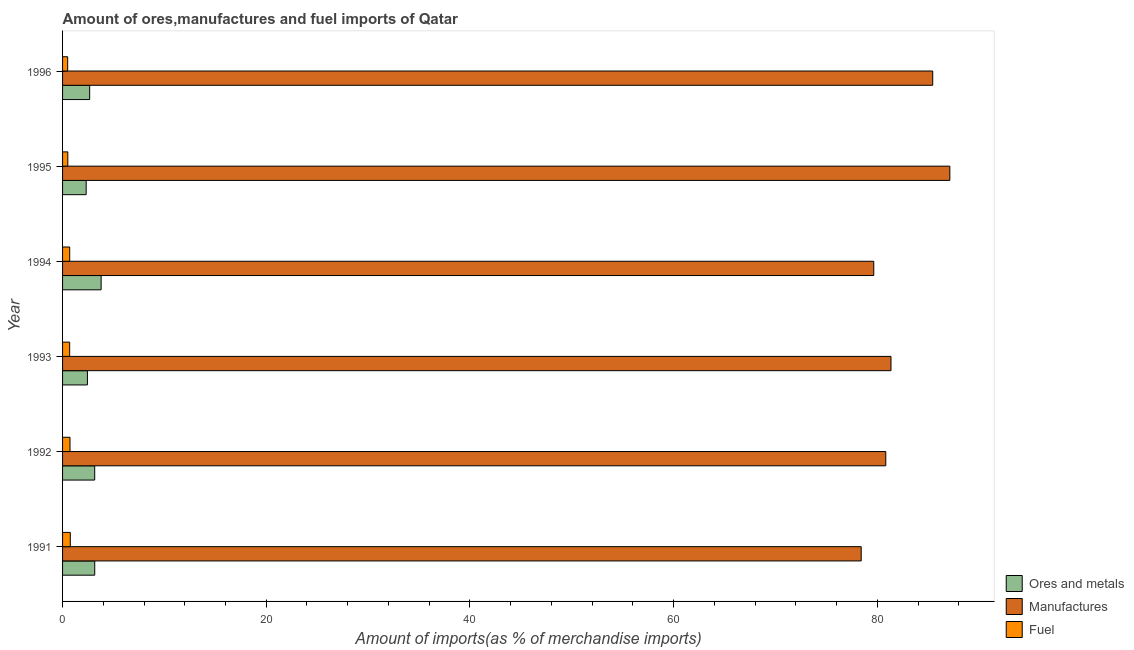How many different coloured bars are there?
Your response must be concise. 3. Are the number of bars per tick equal to the number of legend labels?
Ensure brevity in your answer.  Yes. How many bars are there on the 6th tick from the top?
Keep it short and to the point. 3. How many bars are there on the 1st tick from the bottom?
Make the answer very short. 3. What is the percentage of ores and metals imports in 1991?
Ensure brevity in your answer.  3.16. Across all years, what is the maximum percentage of manufactures imports?
Make the answer very short. 87.12. Across all years, what is the minimum percentage of manufactures imports?
Give a very brief answer. 78.42. In which year was the percentage of manufactures imports maximum?
Your answer should be very brief. 1995. What is the total percentage of ores and metals imports in the graph?
Your answer should be very brief. 17.52. What is the difference between the percentage of fuel imports in 1991 and that in 1995?
Your answer should be very brief. 0.24. What is the difference between the percentage of ores and metals imports in 1995 and the percentage of manufactures imports in 1992?
Provide a short and direct response. -78.51. What is the average percentage of manufactures imports per year?
Your answer should be very brief. 82.13. In the year 1991, what is the difference between the percentage of manufactures imports and percentage of fuel imports?
Offer a terse response. 77.66. In how many years, is the percentage of manufactures imports greater than 72 %?
Your answer should be compact. 6. What is the ratio of the percentage of ores and metals imports in 1991 to that in 1993?
Your response must be concise. 1.29. Is the percentage of fuel imports in 1995 less than that in 1996?
Provide a short and direct response. No. Is the difference between the percentage of manufactures imports in 1993 and 1996 greater than the difference between the percentage of ores and metals imports in 1993 and 1996?
Keep it short and to the point. No. What is the difference between the highest and the second highest percentage of ores and metals imports?
Give a very brief answer. 0.63. What is the difference between the highest and the lowest percentage of ores and metals imports?
Provide a short and direct response. 1.47. In how many years, is the percentage of fuel imports greater than the average percentage of fuel imports taken over all years?
Your answer should be compact. 4. What does the 3rd bar from the top in 1996 represents?
Provide a succinct answer. Ores and metals. What does the 3rd bar from the bottom in 1996 represents?
Your answer should be very brief. Fuel. What is the difference between two consecutive major ticks on the X-axis?
Make the answer very short. 20. How are the legend labels stacked?
Ensure brevity in your answer.  Vertical. What is the title of the graph?
Ensure brevity in your answer.  Amount of ores,manufactures and fuel imports of Qatar. What is the label or title of the X-axis?
Ensure brevity in your answer.  Amount of imports(as % of merchandise imports). What is the Amount of imports(as % of merchandise imports) in Ores and metals in 1991?
Give a very brief answer. 3.16. What is the Amount of imports(as % of merchandise imports) of Manufactures in 1991?
Offer a terse response. 78.42. What is the Amount of imports(as % of merchandise imports) in Fuel in 1991?
Offer a very short reply. 0.76. What is the Amount of imports(as % of merchandise imports) in Ores and metals in 1992?
Give a very brief answer. 3.16. What is the Amount of imports(as % of merchandise imports) of Manufactures in 1992?
Keep it short and to the point. 80.83. What is the Amount of imports(as % of merchandise imports) of Fuel in 1992?
Your answer should be very brief. 0.73. What is the Amount of imports(as % of merchandise imports) in Ores and metals in 1993?
Keep it short and to the point. 2.44. What is the Amount of imports(as % of merchandise imports) in Manufactures in 1993?
Provide a short and direct response. 81.34. What is the Amount of imports(as % of merchandise imports) of Fuel in 1993?
Your answer should be compact. 0.7. What is the Amount of imports(as % of merchandise imports) in Ores and metals in 1994?
Offer a very short reply. 3.79. What is the Amount of imports(as % of merchandise imports) in Manufactures in 1994?
Provide a succinct answer. 79.65. What is the Amount of imports(as % of merchandise imports) of Fuel in 1994?
Provide a short and direct response. 0.7. What is the Amount of imports(as % of merchandise imports) in Ores and metals in 1995?
Give a very brief answer. 2.32. What is the Amount of imports(as % of merchandise imports) in Manufactures in 1995?
Provide a short and direct response. 87.12. What is the Amount of imports(as % of merchandise imports) of Fuel in 1995?
Ensure brevity in your answer.  0.52. What is the Amount of imports(as % of merchandise imports) of Ores and metals in 1996?
Your answer should be very brief. 2.66. What is the Amount of imports(as % of merchandise imports) in Manufactures in 1996?
Provide a succinct answer. 85.44. What is the Amount of imports(as % of merchandise imports) in Fuel in 1996?
Keep it short and to the point. 0.5. Across all years, what is the maximum Amount of imports(as % of merchandise imports) of Ores and metals?
Offer a very short reply. 3.79. Across all years, what is the maximum Amount of imports(as % of merchandise imports) in Manufactures?
Provide a succinct answer. 87.12. Across all years, what is the maximum Amount of imports(as % of merchandise imports) in Fuel?
Offer a terse response. 0.76. Across all years, what is the minimum Amount of imports(as % of merchandise imports) of Ores and metals?
Your answer should be very brief. 2.32. Across all years, what is the minimum Amount of imports(as % of merchandise imports) of Manufactures?
Make the answer very short. 78.42. Across all years, what is the minimum Amount of imports(as % of merchandise imports) of Fuel?
Provide a succinct answer. 0.5. What is the total Amount of imports(as % of merchandise imports) in Ores and metals in the graph?
Offer a very short reply. 17.52. What is the total Amount of imports(as % of merchandise imports) of Manufactures in the graph?
Offer a very short reply. 492.8. What is the total Amount of imports(as % of merchandise imports) of Fuel in the graph?
Provide a succinct answer. 3.9. What is the difference between the Amount of imports(as % of merchandise imports) in Ores and metals in 1991 and that in 1992?
Offer a terse response. 0. What is the difference between the Amount of imports(as % of merchandise imports) in Manufactures in 1991 and that in 1992?
Provide a succinct answer. -2.41. What is the difference between the Amount of imports(as % of merchandise imports) of Fuel in 1991 and that in 1992?
Your answer should be compact. 0.03. What is the difference between the Amount of imports(as % of merchandise imports) in Ores and metals in 1991 and that in 1993?
Provide a short and direct response. 0.72. What is the difference between the Amount of imports(as % of merchandise imports) in Manufactures in 1991 and that in 1993?
Give a very brief answer. -2.92. What is the difference between the Amount of imports(as % of merchandise imports) of Fuel in 1991 and that in 1993?
Your answer should be very brief. 0.06. What is the difference between the Amount of imports(as % of merchandise imports) in Ores and metals in 1991 and that in 1994?
Offer a terse response. -0.63. What is the difference between the Amount of imports(as % of merchandise imports) in Manufactures in 1991 and that in 1994?
Keep it short and to the point. -1.23. What is the difference between the Amount of imports(as % of merchandise imports) of Fuel in 1991 and that in 1994?
Offer a very short reply. 0.06. What is the difference between the Amount of imports(as % of merchandise imports) of Ores and metals in 1991 and that in 1995?
Give a very brief answer. 0.84. What is the difference between the Amount of imports(as % of merchandise imports) in Manufactures in 1991 and that in 1995?
Provide a short and direct response. -8.7. What is the difference between the Amount of imports(as % of merchandise imports) in Fuel in 1991 and that in 1995?
Your answer should be compact. 0.24. What is the difference between the Amount of imports(as % of merchandise imports) in Ores and metals in 1991 and that in 1996?
Offer a terse response. 0.5. What is the difference between the Amount of imports(as % of merchandise imports) of Manufactures in 1991 and that in 1996?
Provide a succinct answer. -7.02. What is the difference between the Amount of imports(as % of merchandise imports) in Fuel in 1991 and that in 1996?
Your answer should be very brief. 0.26. What is the difference between the Amount of imports(as % of merchandise imports) in Ores and metals in 1992 and that in 1993?
Your answer should be compact. 0.72. What is the difference between the Amount of imports(as % of merchandise imports) of Manufactures in 1992 and that in 1993?
Make the answer very short. -0.51. What is the difference between the Amount of imports(as % of merchandise imports) of Fuel in 1992 and that in 1993?
Your answer should be compact. 0.03. What is the difference between the Amount of imports(as % of merchandise imports) of Ores and metals in 1992 and that in 1994?
Your response must be concise. -0.63. What is the difference between the Amount of imports(as % of merchandise imports) of Manufactures in 1992 and that in 1994?
Provide a short and direct response. 1.18. What is the difference between the Amount of imports(as % of merchandise imports) of Fuel in 1992 and that in 1994?
Your answer should be very brief. 0.03. What is the difference between the Amount of imports(as % of merchandise imports) in Ores and metals in 1992 and that in 1995?
Ensure brevity in your answer.  0.84. What is the difference between the Amount of imports(as % of merchandise imports) in Manufactures in 1992 and that in 1995?
Offer a very short reply. -6.29. What is the difference between the Amount of imports(as % of merchandise imports) of Fuel in 1992 and that in 1995?
Provide a short and direct response. 0.21. What is the difference between the Amount of imports(as % of merchandise imports) in Ores and metals in 1992 and that in 1996?
Provide a short and direct response. 0.49. What is the difference between the Amount of imports(as % of merchandise imports) in Manufactures in 1992 and that in 1996?
Your answer should be compact. -4.61. What is the difference between the Amount of imports(as % of merchandise imports) in Fuel in 1992 and that in 1996?
Your answer should be very brief. 0.23. What is the difference between the Amount of imports(as % of merchandise imports) in Ores and metals in 1993 and that in 1994?
Your answer should be very brief. -1.35. What is the difference between the Amount of imports(as % of merchandise imports) of Manufactures in 1993 and that in 1994?
Provide a succinct answer. 1.69. What is the difference between the Amount of imports(as % of merchandise imports) in Fuel in 1993 and that in 1994?
Make the answer very short. -0. What is the difference between the Amount of imports(as % of merchandise imports) in Ores and metals in 1993 and that in 1995?
Give a very brief answer. 0.12. What is the difference between the Amount of imports(as % of merchandise imports) in Manufactures in 1993 and that in 1995?
Your response must be concise. -5.78. What is the difference between the Amount of imports(as % of merchandise imports) in Fuel in 1993 and that in 1995?
Your answer should be compact. 0.18. What is the difference between the Amount of imports(as % of merchandise imports) in Ores and metals in 1993 and that in 1996?
Offer a very short reply. -0.22. What is the difference between the Amount of imports(as % of merchandise imports) of Manufactures in 1993 and that in 1996?
Make the answer very short. -4.1. What is the difference between the Amount of imports(as % of merchandise imports) in Fuel in 1993 and that in 1996?
Ensure brevity in your answer.  0.2. What is the difference between the Amount of imports(as % of merchandise imports) in Ores and metals in 1994 and that in 1995?
Give a very brief answer. 1.47. What is the difference between the Amount of imports(as % of merchandise imports) in Manufactures in 1994 and that in 1995?
Your answer should be compact. -7.47. What is the difference between the Amount of imports(as % of merchandise imports) in Fuel in 1994 and that in 1995?
Make the answer very short. 0.18. What is the difference between the Amount of imports(as % of merchandise imports) in Manufactures in 1994 and that in 1996?
Your answer should be compact. -5.79. What is the difference between the Amount of imports(as % of merchandise imports) in Ores and metals in 1995 and that in 1996?
Provide a succinct answer. -0.34. What is the difference between the Amount of imports(as % of merchandise imports) in Manufactures in 1995 and that in 1996?
Offer a terse response. 1.68. What is the difference between the Amount of imports(as % of merchandise imports) of Fuel in 1995 and that in 1996?
Your response must be concise. 0.02. What is the difference between the Amount of imports(as % of merchandise imports) of Ores and metals in 1991 and the Amount of imports(as % of merchandise imports) of Manufactures in 1992?
Your answer should be very brief. -77.67. What is the difference between the Amount of imports(as % of merchandise imports) of Ores and metals in 1991 and the Amount of imports(as % of merchandise imports) of Fuel in 1992?
Make the answer very short. 2.43. What is the difference between the Amount of imports(as % of merchandise imports) in Manufactures in 1991 and the Amount of imports(as % of merchandise imports) in Fuel in 1992?
Give a very brief answer. 77.69. What is the difference between the Amount of imports(as % of merchandise imports) in Ores and metals in 1991 and the Amount of imports(as % of merchandise imports) in Manufactures in 1993?
Your answer should be compact. -78.18. What is the difference between the Amount of imports(as % of merchandise imports) of Ores and metals in 1991 and the Amount of imports(as % of merchandise imports) of Fuel in 1993?
Your answer should be compact. 2.46. What is the difference between the Amount of imports(as % of merchandise imports) in Manufactures in 1991 and the Amount of imports(as % of merchandise imports) in Fuel in 1993?
Your answer should be compact. 77.72. What is the difference between the Amount of imports(as % of merchandise imports) in Ores and metals in 1991 and the Amount of imports(as % of merchandise imports) in Manufactures in 1994?
Provide a succinct answer. -76.49. What is the difference between the Amount of imports(as % of merchandise imports) in Ores and metals in 1991 and the Amount of imports(as % of merchandise imports) in Fuel in 1994?
Provide a short and direct response. 2.46. What is the difference between the Amount of imports(as % of merchandise imports) of Manufactures in 1991 and the Amount of imports(as % of merchandise imports) of Fuel in 1994?
Offer a very short reply. 77.72. What is the difference between the Amount of imports(as % of merchandise imports) of Ores and metals in 1991 and the Amount of imports(as % of merchandise imports) of Manufactures in 1995?
Ensure brevity in your answer.  -83.96. What is the difference between the Amount of imports(as % of merchandise imports) of Ores and metals in 1991 and the Amount of imports(as % of merchandise imports) of Fuel in 1995?
Provide a short and direct response. 2.64. What is the difference between the Amount of imports(as % of merchandise imports) of Manufactures in 1991 and the Amount of imports(as % of merchandise imports) of Fuel in 1995?
Make the answer very short. 77.9. What is the difference between the Amount of imports(as % of merchandise imports) in Ores and metals in 1991 and the Amount of imports(as % of merchandise imports) in Manufactures in 1996?
Keep it short and to the point. -82.28. What is the difference between the Amount of imports(as % of merchandise imports) in Ores and metals in 1991 and the Amount of imports(as % of merchandise imports) in Fuel in 1996?
Offer a terse response. 2.66. What is the difference between the Amount of imports(as % of merchandise imports) of Manufactures in 1991 and the Amount of imports(as % of merchandise imports) of Fuel in 1996?
Your response must be concise. 77.92. What is the difference between the Amount of imports(as % of merchandise imports) of Ores and metals in 1992 and the Amount of imports(as % of merchandise imports) of Manufactures in 1993?
Provide a succinct answer. -78.19. What is the difference between the Amount of imports(as % of merchandise imports) of Ores and metals in 1992 and the Amount of imports(as % of merchandise imports) of Fuel in 1993?
Provide a succinct answer. 2.46. What is the difference between the Amount of imports(as % of merchandise imports) in Manufactures in 1992 and the Amount of imports(as % of merchandise imports) in Fuel in 1993?
Your answer should be compact. 80.13. What is the difference between the Amount of imports(as % of merchandise imports) in Ores and metals in 1992 and the Amount of imports(as % of merchandise imports) in Manufactures in 1994?
Make the answer very short. -76.5. What is the difference between the Amount of imports(as % of merchandise imports) in Ores and metals in 1992 and the Amount of imports(as % of merchandise imports) in Fuel in 1994?
Your answer should be very brief. 2.45. What is the difference between the Amount of imports(as % of merchandise imports) in Manufactures in 1992 and the Amount of imports(as % of merchandise imports) in Fuel in 1994?
Provide a short and direct response. 80.13. What is the difference between the Amount of imports(as % of merchandise imports) of Ores and metals in 1992 and the Amount of imports(as % of merchandise imports) of Manufactures in 1995?
Provide a short and direct response. -83.97. What is the difference between the Amount of imports(as % of merchandise imports) in Ores and metals in 1992 and the Amount of imports(as % of merchandise imports) in Fuel in 1995?
Keep it short and to the point. 2.64. What is the difference between the Amount of imports(as % of merchandise imports) of Manufactures in 1992 and the Amount of imports(as % of merchandise imports) of Fuel in 1995?
Your response must be concise. 80.31. What is the difference between the Amount of imports(as % of merchandise imports) of Ores and metals in 1992 and the Amount of imports(as % of merchandise imports) of Manufactures in 1996?
Your answer should be very brief. -82.28. What is the difference between the Amount of imports(as % of merchandise imports) of Ores and metals in 1992 and the Amount of imports(as % of merchandise imports) of Fuel in 1996?
Your answer should be very brief. 2.65. What is the difference between the Amount of imports(as % of merchandise imports) in Manufactures in 1992 and the Amount of imports(as % of merchandise imports) in Fuel in 1996?
Offer a very short reply. 80.33. What is the difference between the Amount of imports(as % of merchandise imports) in Ores and metals in 1993 and the Amount of imports(as % of merchandise imports) in Manufactures in 1994?
Provide a short and direct response. -77.21. What is the difference between the Amount of imports(as % of merchandise imports) of Ores and metals in 1993 and the Amount of imports(as % of merchandise imports) of Fuel in 1994?
Make the answer very short. 1.74. What is the difference between the Amount of imports(as % of merchandise imports) in Manufactures in 1993 and the Amount of imports(as % of merchandise imports) in Fuel in 1994?
Offer a terse response. 80.64. What is the difference between the Amount of imports(as % of merchandise imports) in Ores and metals in 1993 and the Amount of imports(as % of merchandise imports) in Manufactures in 1995?
Keep it short and to the point. -84.68. What is the difference between the Amount of imports(as % of merchandise imports) of Ores and metals in 1993 and the Amount of imports(as % of merchandise imports) of Fuel in 1995?
Your answer should be very brief. 1.92. What is the difference between the Amount of imports(as % of merchandise imports) in Manufactures in 1993 and the Amount of imports(as % of merchandise imports) in Fuel in 1995?
Provide a short and direct response. 80.83. What is the difference between the Amount of imports(as % of merchandise imports) of Ores and metals in 1993 and the Amount of imports(as % of merchandise imports) of Manufactures in 1996?
Offer a very short reply. -83. What is the difference between the Amount of imports(as % of merchandise imports) of Ores and metals in 1993 and the Amount of imports(as % of merchandise imports) of Fuel in 1996?
Give a very brief answer. 1.94. What is the difference between the Amount of imports(as % of merchandise imports) in Manufactures in 1993 and the Amount of imports(as % of merchandise imports) in Fuel in 1996?
Provide a short and direct response. 80.84. What is the difference between the Amount of imports(as % of merchandise imports) of Ores and metals in 1994 and the Amount of imports(as % of merchandise imports) of Manufactures in 1995?
Offer a very short reply. -83.33. What is the difference between the Amount of imports(as % of merchandise imports) in Ores and metals in 1994 and the Amount of imports(as % of merchandise imports) in Fuel in 1995?
Keep it short and to the point. 3.27. What is the difference between the Amount of imports(as % of merchandise imports) of Manufactures in 1994 and the Amount of imports(as % of merchandise imports) of Fuel in 1995?
Offer a very short reply. 79.13. What is the difference between the Amount of imports(as % of merchandise imports) in Ores and metals in 1994 and the Amount of imports(as % of merchandise imports) in Manufactures in 1996?
Offer a very short reply. -81.65. What is the difference between the Amount of imports(as % of merchandise imports) in Ores and metals in 1994 and the Amount of imports(as % of merchandise imports) in Fuel in 1996?
Your response must be concise. 3.29. What is the difference between the Amount of imports(as % of merchandise imports) of Manufactures in 1994 and the Amount of imports(as % of merchandise imports) of Fuel in 1996?
Offer a terse response. 79.15. What is the difference between the Amount of imports(as % of merchandise imports) of Ores and metals in 1995 and the Amount of imports(as % of merchandise imports) of Manufactures in 1996?
Ensure brevity in your answer.  -83.12. What is the difference between the Amount of imports(as % of merchandise imports) of Ores and metals in 1995 and the Amount of imports(as % of merchandise imports) of Fuel in 1996?
Offer a terse response. 1.82. What is the difference between the Amount of imports(as % of merchandise imports) of Manufactures in 1995 and the Amount of imports(as % of merchandise imports) of Fuel in 1996?
Keep it short and to the point. 86.62. What is the average Amount of imports(as % of merchandise imports) of Ores and metals per year?
Your answer should be very brief. 2.92. What is the average Amount of imports(as % of merchandise imports) of Manufactures per year?
Provide a succinct answer. 82.13. What is the average Amount of imports(as % of merchandise imports) in Fuel per year?
Provide a short and direct response. 0.65. In the year 1991, what is the difference between the Amount of imports(as % of merchandise imports) in Ores and metals and Amount of imports(as % of merchandise imports) in Manufactures?
Your answer should be compact. -75.26. In the year 1991, what is the difference between the Amount of imports(as % of merchandise imports) of Ores and metals and Amount of imports(as % of merchandise imports) of Fuel?
Ensure brevity in your answer.  2.4. In the year 1991, what is the difference between the Amount of imports(as % of merchandise imports) of Manufactures and Amount of imports(as % of merchandise imports) of Fuel?
Give a very brief answer. 77.66. In the year 1992, what is the difference between the Amount of imports(as % of merchandise imports) in Ores and metals and Amount of imports(as % of merchandise imports) in Manufactures?
Give a very brief answer. -77.68. In the year 1992, what is the difference between the Amount of imports(as % of merchandise imports) of Ores and metals and Amount of imports(as % of merchandise imports) of Fuel?
Provide a short and direct response. 2.43. In the year 1992, what is the difference between the Amount of imports(as % of merchandise imports) of Manufactures and Amount of imports(as % of merchandise imports) of Fuel?
Your answer should be very brief. 80.1. In the year 1993, what is the difference between the Amount of imports(as % of merchandise imports) in Ores and metals and Amount of imports(as % of merchandise imports) in Manufactures?
Offer a terse response. -78.9. In the year 1993, what is the difference between the Amount of imports(as % of merchandise imports) in Ores and metals and Amount of imports(as % of merchandise imports) in Fuel?
Your answer should be very brief. 1.74. In the year 1993, what is the difference between the Amount of imports(as % of merchandise imports) of Manufactures and Amount of imports(as % of merchandise imports) of Fuel?
Offer a very short reply. 80.64. In the year 1994, what is the difference between the Amount of imports(as % of merchandise imports) of Ores and metals and Amount of imports(as % of merchandise imports) of Manufactures?
Make the answer very short. -75.86. In the year 1994, what is the difference between the Amount of imports(as % of merchandise imports) of Ores and metals and Amount of imports(as % of merchandise imports) of Fuel?
Offer a terse response. 3.09. In the year 1994, what is the difference between the Amount of imports(as % of merchandise imports) in Manufactures and Amount of imports(as % of merchandise imports) in Fuel?
Your response must be concise. 78.95. In the year 1995, what is the difference between the Amount of imports(as % of merchandise imports) in Ores and metals and Amount of imports(as % of merchandise imports) in Manufactures?
Provide a short and direct response. -84.8. In the year 1995, what is the difference between the Amount of imports(as % of merchandise imports) in Ores and metals and Amount of imports(as % of merchandise imports) in Fuel?
Your answer should be very brief. 1.8. In the year 1995, what is the difference between the Amount of imports(as % of merchandise imports) in Manufactures and Amount of imports(as % of merchandise imports) in Fuel?
Provide a succinct answer. 86.61. In the year 1996, what is the difference between the Amount of imports(as % of merchandise imports) in Ores and metals and Amount of imports(as % of merchandise imports) in Manufactures?
Make the answer very short. -82.78. In the year 1996, what is the difference between the Amount of imports(as % of merchandise imports) in Ores and metals and Amount of imports(as % of merchandise imports) in Fuel?
Provide a succinct answer. 2.16. In the year 1996, what is the difference between the Amount of imports(as % of merchandise imports) in Manufactures and Amount of imports(as % of merchandise imports) in Fuel?
Offer a terse response. 84.94. What is the ratio of the Amount of imports(as % of merchandise imports) in Ores and metals in 1991 to that in 1992?
Offer a terse response. 1. What is the ratio of the Amount of imports(as % of merchandise imports) of Manufactures in 1991 to that in 1992?
Ensure brevity in your answer.  0.97. What is the ratio of the Amount of imports(as % of merchandise imports) in Fuel in 1991 to that in 1992?
Provide a short and direct response. 1.04. What is the ratio of the Amount of imports(as % of merchandise imports) of Ores and metals in 1991 to that in 1993?
Ensure brevity in your answer.  1.29. What is the ratio of the Amount of imports(as % of merchandise imports) in Fuel in 1991 to that in 1993?
Your response must be concise. 1.09. What is the ratio of the Amount of imports(as % of merchandise imports) in Ores and metals in 1991 to that in 1994?
Your answer should be compact. 0.83. What is the ratio of the Amount of imports(as % of merchandise imports) in Manufactures in 1991 to that in 1994?
Give a very brief answer. 0.98. What is the ratio of the Amount of imports(as % of merchandise imports) in Fuel in 1991 to that in 1994?
Your answer should be very brief. 1.08. What is the ratio of the Amount of imports(as % of merchandise imports) of Ores and metals in 1991 to that in 1995?
Give a very brief answer. 1.36. What is the ratio of the Amount of imports(as % of merchandise imports) of Manufactures in 1991 to that in 1995?
Your answer should be compact. 0.9. What is the ratio of the Amount of imports(as % of merchandise imports) of Fuel in 1991 to that in 1995?
Offer a terse response. 1.47. What is the ratio of the Amount of imports(as % of merchandise imports) of Ores and metals in 1991 to that in 1996?
Offer a very short reply. 1.19. What is the ratio of the Amount of imports(as % of merchandise imports) of Manufactures in 1991 to that in 1996?
Provide a short and direct response. 0.92. What is the ratio of the Amount of imports(as % of merchandise imports) of Fuel in 1991 to that in 1996?
Provide a succinct answer. 1.52. What is the ratio of the Amount of imports(as % of merchandise imports) of Ores and metals in 1992 to that in 1993?
Your answer should be compact. 1.29. What is the ratio of the Amount of imports(as % of merchandise imports) of Manufactures in 1992 to that in 1993?
Ensure brevity in your answer.  0.99. What is the ratio of the Amount of imports(as % of merchandise imports) of Fuel in 1992 to that in 1993?
Offer a terse response. 1.05. What is the ratio of the Amount of imports(as % of merchandise imports) in Manufactures in 1992 to that in 1994?
Provide a succinct answer. 1.01. What is the ratio of the Amount of imports(as % of merchandise imports) in Fuel in 1992 to that in 1994?
Provide a short and direct response. 1.04. What is the ratio of the Amount of imports(as % of merchandise imports) in Ores and metals in 1992 to that in 1995?
Your response must be concise. 1.36. What is the ratio of the Amount of imports(as % of merchandise imports) of Manufactures in 1992 to that in 1995?
Offer a terse response. 0.93. What is the ratio of the Amount of imports(as % of merchandise imports) in Fuel in 1992 to that in 1995?
Offer a terse response. 1.41. What is the ratio of the Amount of imports(as % of merchandise imports) in Ores and metals in 1992 to that in 1996?
Provide a short and direct response. 1.19. What is the ratio of the Amount of imports(as % of merchandise imports) in Manufactures in 1992 to that in 1996?
Offer a very short reply. 0.95. What is the ratio of the Amount of imports(as % of merchandise imports) in Fuel in 1992 to that in 1996?
Provide a short and direct response. 1.46. What is the ratio of the Amount of imports(as % of merchandise imports) in Ores and metals in 1993 to that in 1994?
Your response must be concise. 0.64. What is the ratio of the Amount of imports(as % of merchandise imports) in Manufactures in 1993 to that in 1994?
Give a very brief answer. 1.02. What is the ratio of the Amount of imports(as % of merchandise imports) in Fuel in 1993 to that in 1994?
Offer a terse response. 1. What is the ratio of the Amount of imports(as % of merchandise imports) in Ores and metals in 1993 to that in 1995?
Your response must be concise. 1.05. What is the ratio of the Amount of imports(as % of merchandise imports) of Manufactures in 1993 to that in 1995?
Provide a short and direct response. 0.93. What is the ratio of the Amount of imports(as % of merchandise imports) in Fuel in 1993 to that in 1995?
Give a very brief answer. 1.35. What is the ratio of the Amount of imports(as % of merchandise imports) in Ores and metals in 1993 to that in 1996?
Offer a terse response. 0.92. What is the ratio of the Amount of imports(as % of merchandise imports) in Fuel in 1993 to that in 1996?
Your response must be concise. 1.39. What is the ratio of the Amount of imports(as % of merchandise imports) of Ores and metals in 1994 to that in 1995?
Offer a very short reply. 1.63. What is the ratio of the Amount of imports(as % of merchandise imports) in Manufactures in 1994 to that in 1995?
Keep it short and to the point. 0.91. What is the ratio of the Amount of imports(as % of merchandise imports) in Fuel in 1994 to that in 1995?
Give a very brief answer. 1.36. What is the ratio of the Amount of imports(as % of merchandise imports) in Ores and metals in 1994 to that in 1996?
Ensure brevity in your answer.  1.42. What is the ratio of the Amount of imports(as % of merchandise imports) in Manufactures in 1994 to that in 1996?
Your answer should be compact. 0.93. What is the ratio of the Amount of imports(as % of merchandise imports) in Fuel in 1994 to that in 1996?
Provide a succinct answer. 1.4. What is the ratio of the Amount of imports(as % of merchandise imports) in Ores and metals in 1995 to that in 1996?
Your response must be concise. 0.87. What is the ratio of the Amount of imports(as % of merchandise imports) of Manufactures in 1995 to that in 1996?
Your response must be concise. 1.02. What is the ratio of the Amount of imports(as % of merchandise imports) in Fuel in 1995 to that in 1996?
Offer a very short reply. 1.03. What is the difference between the highest and the second highest Amount of imports(as % of merchandise imports) in Ores and metals?
Provide a succinct answer. 0.63. What is the difference between the highest and the second highest Amount of imports(as % of merchandise imports) of Manufactures?
Ensure brevity in your answer.  1.68. What is the difference between the highest and the second highest Amount of imports(as % of merchandise imports) of Fuel?
Provide a short and direct response. 0.03. What is the difference between the highest and the lowest Amount of imports(as % of merchandise imports) of Ores and metals?
Make the answer very short. 1.47. What is the difference between the highest and the lowest Amount of imports(as % of merchandise imports) in Manufactures?
Your response must be concise. 8.7. What is the difference between the highest and the lowest Amount of imports(as % of merchandise imports) in Fuel?
Ensure brevity in your answer.  0.26. 